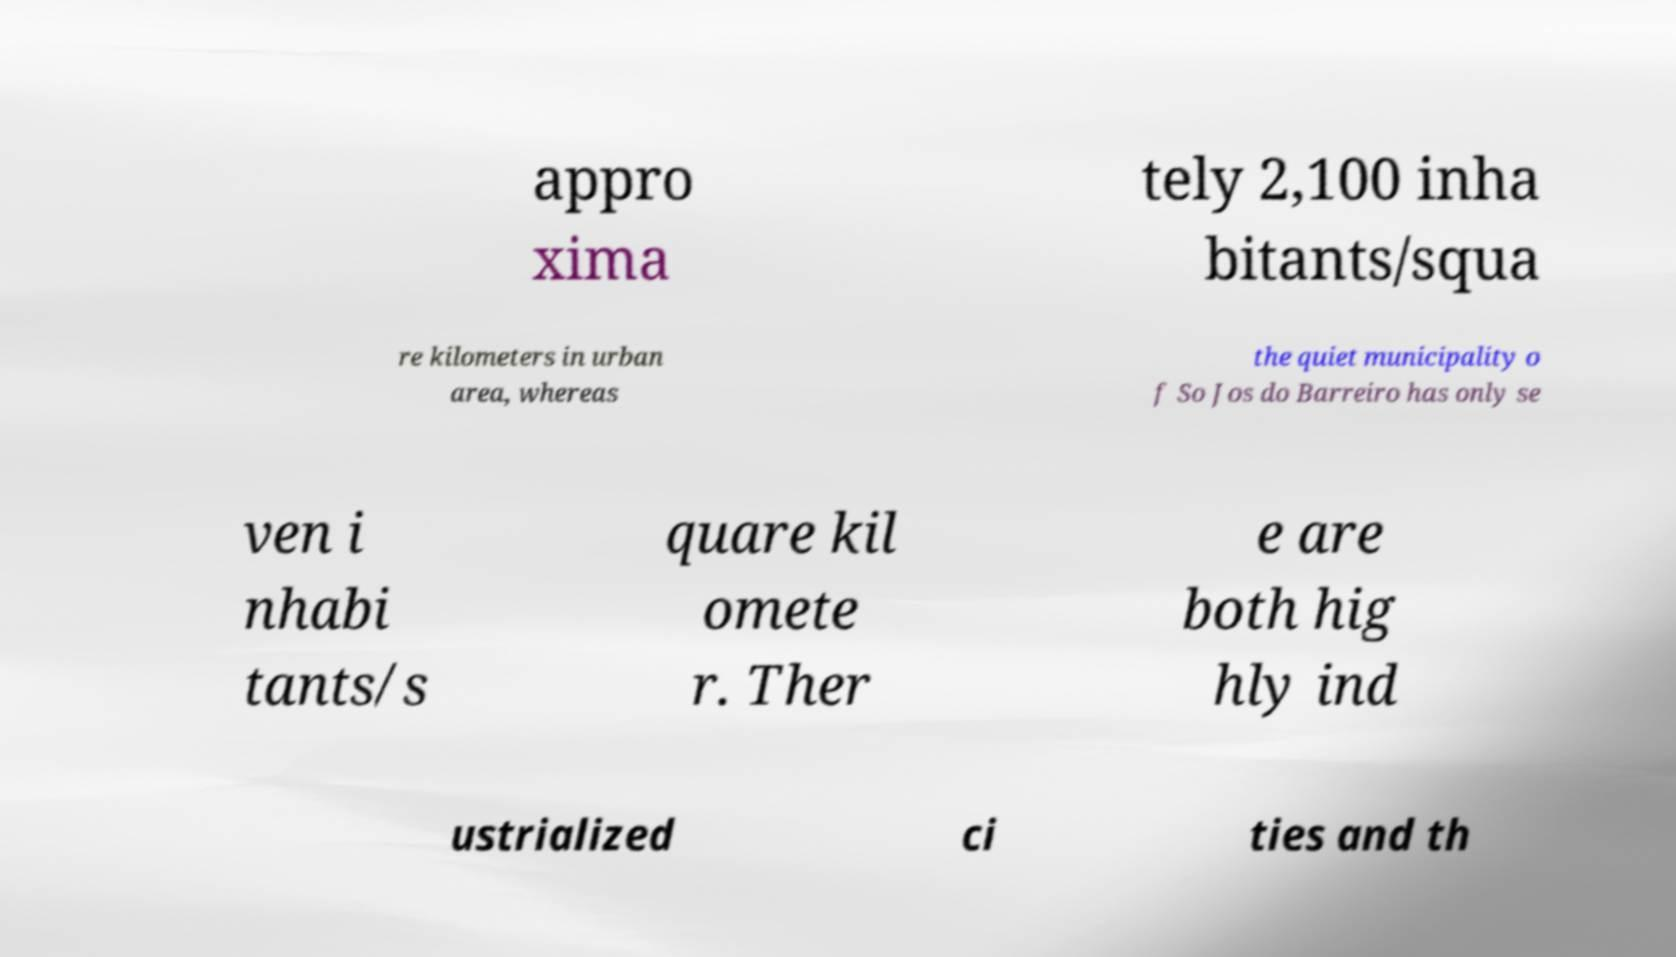Could you extract and type out the text from this image? appro xima tely 2,100 inha bitants/squa re kilometers in urban area, whereas the quiet municipality o f So Jos do Barreiro has only se ven i nhabi tants/s quare kil omete r. Ther e are both hig hly ind ustrialized ci ties and th 